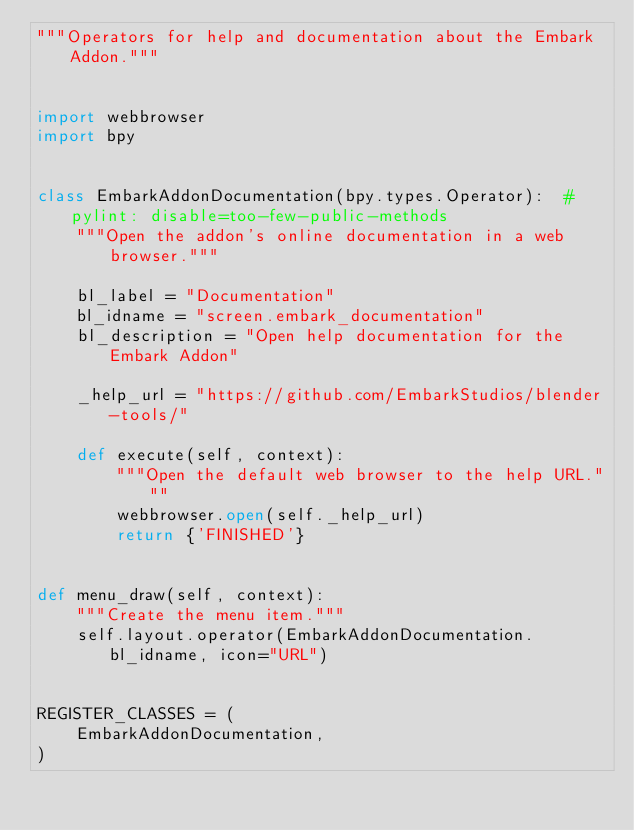Convert code to text. <code><loc_0><loc_0><loc_500><loc_500><_Python_>"""Operators for help and documentation about the Embark Addon."""


import webbrowser
import bpy


class EmbarkAddonDocumentation(bpy.types.Operator):  # pylint: disable=too-few-public-methods
    """Open the addon's online documentation in a web browser."""

    bl_label = "Documentation"
    bl_idname = "screen.embark_documentation"
    bl_description = "Open help documentation for the Embark Addon"

    _help_url = "https://github.com/EmbarkStudios/blender-tools/"

    def execute(self, context):
        """Open the default web browser to the help URL."""
        webbrowser.open(self._help_url)
        return {'FINISHED'}


def menu_draw(self, context):
    """Create the menu item."""
    self.layout.operator(EmbarkAddonDocumentation.bl_idname, icon="URL")


REGISTER_CLASSES = (
    EmbarkAddonDocumentation,
)
</code> 